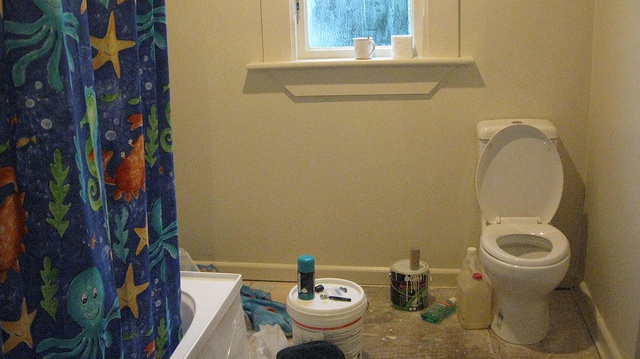Describe the objects in this image and their specific colors. I can see toilet in olive, tan, and gray tones, cup in olive, tan, and lightgray tones, and cup in olive, tan, and lightgray tones in this image. 